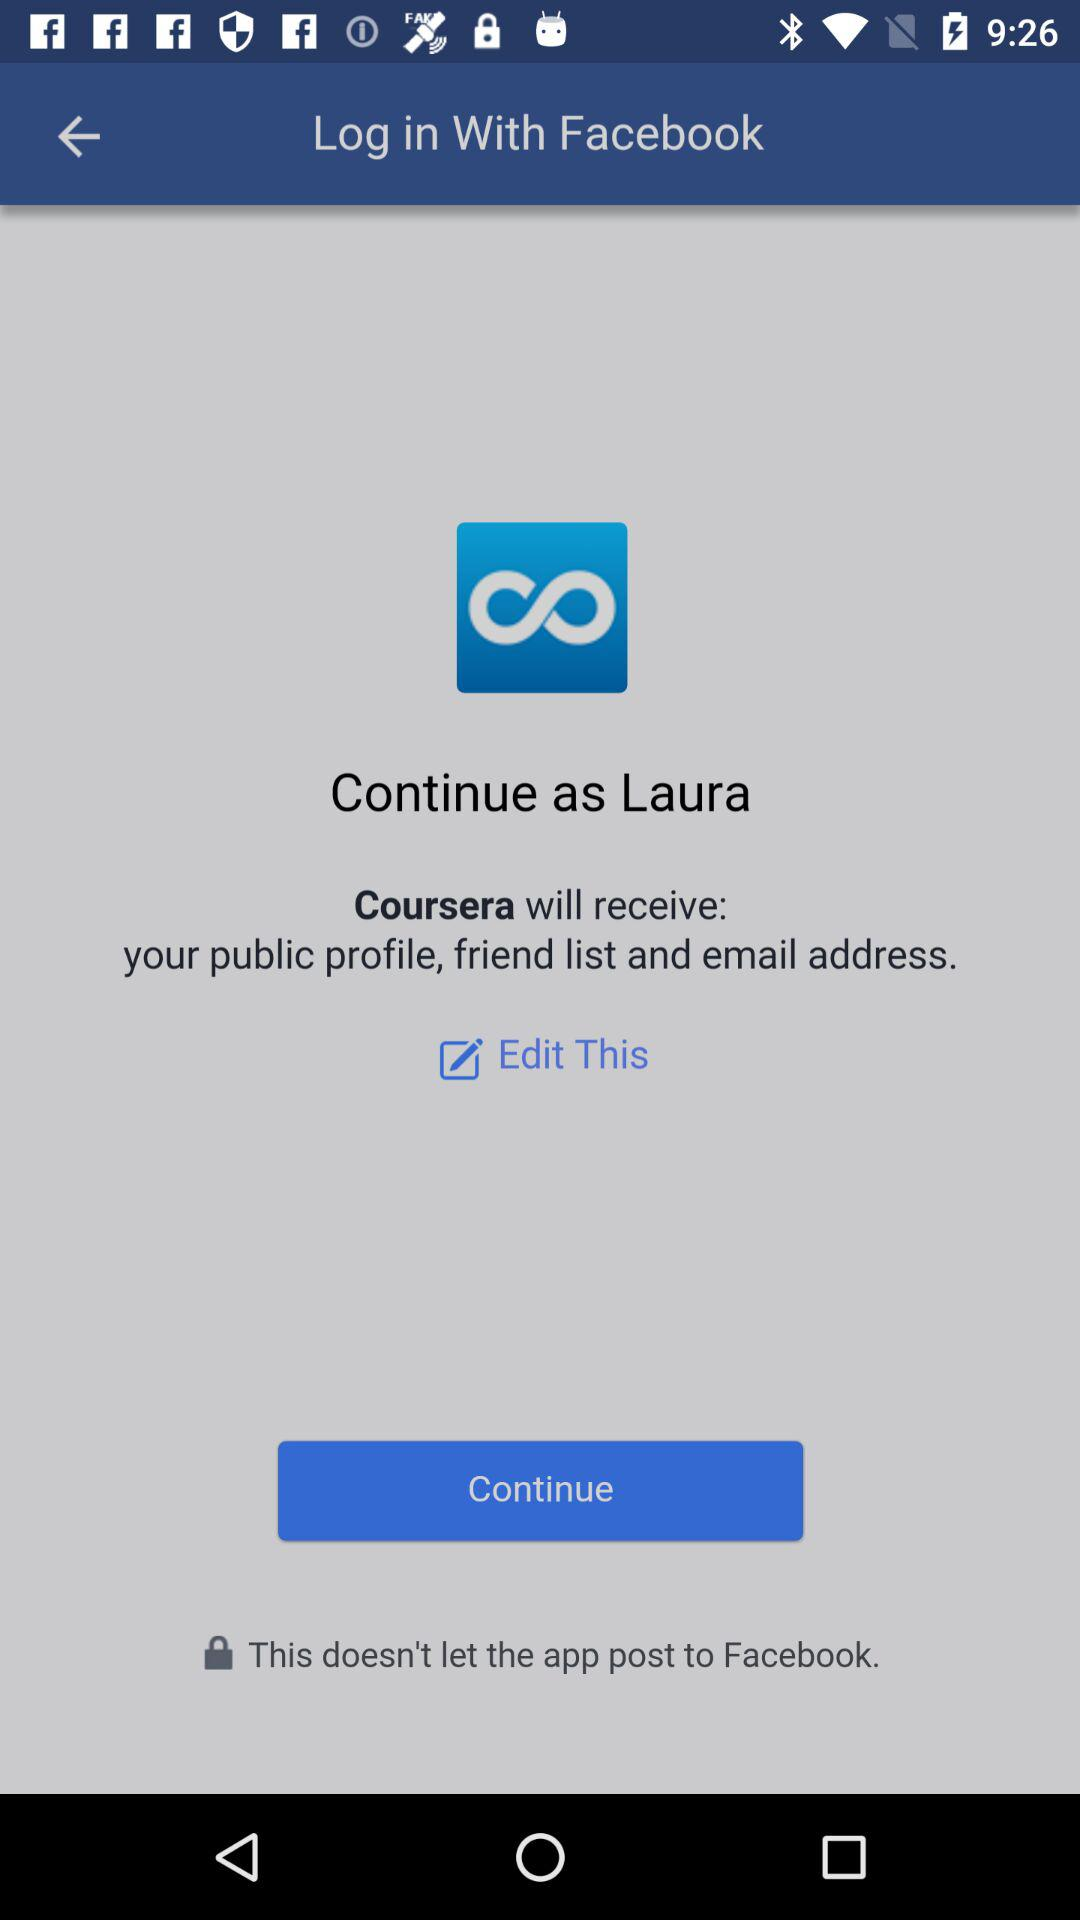What is the login name? The login name is "Laura". 